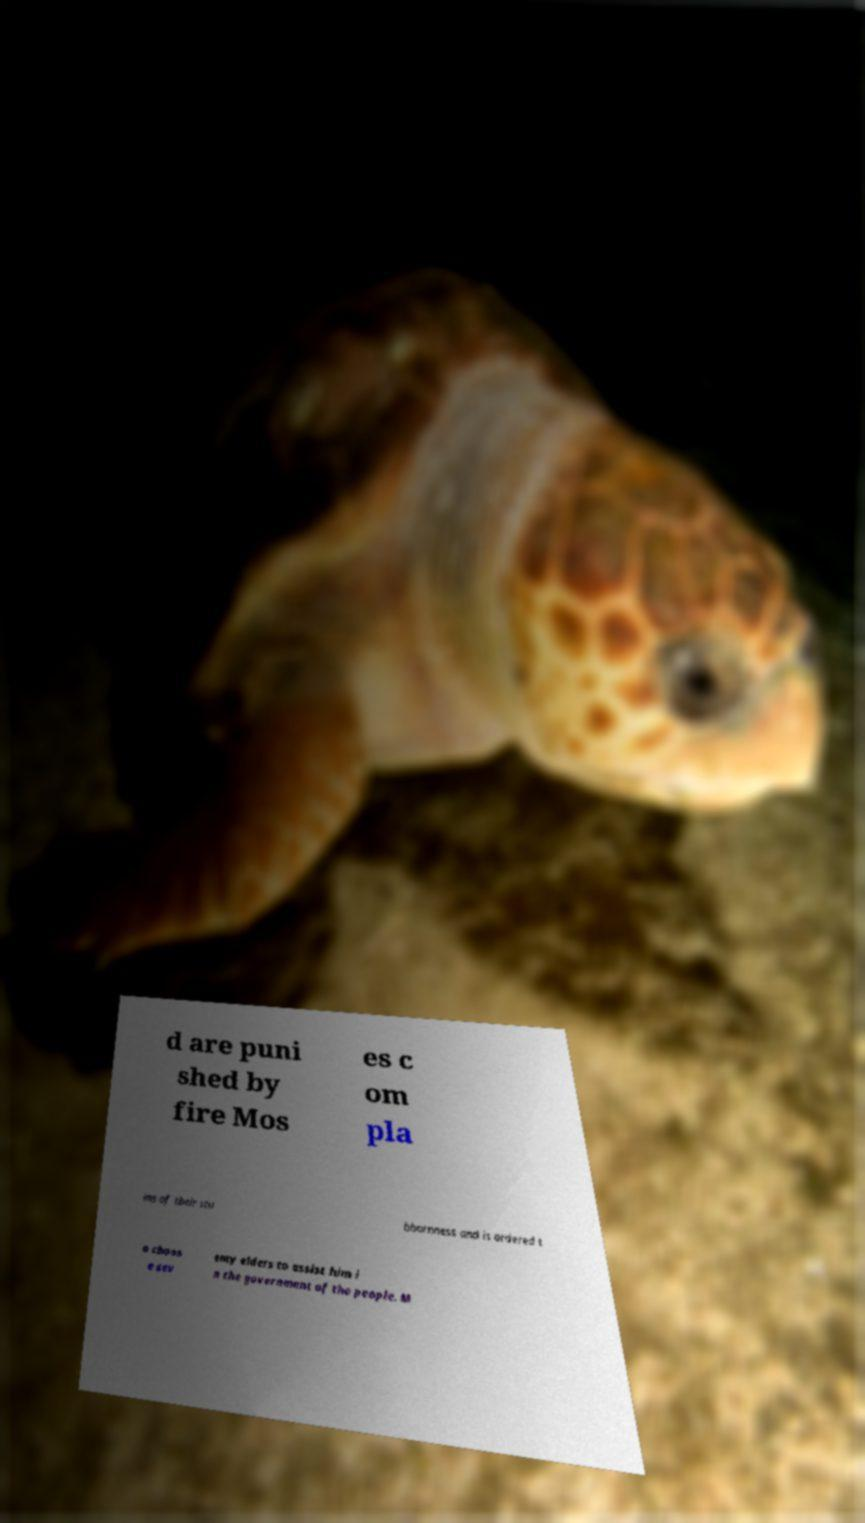For documentation purposes, I need the text within this image transcribed. Could you provide that? d are puni shed by fire Mos es c om pla ins of their stu bbornness and is ordered t o choos e sev enty elders to assist him i n the government of the people. M 